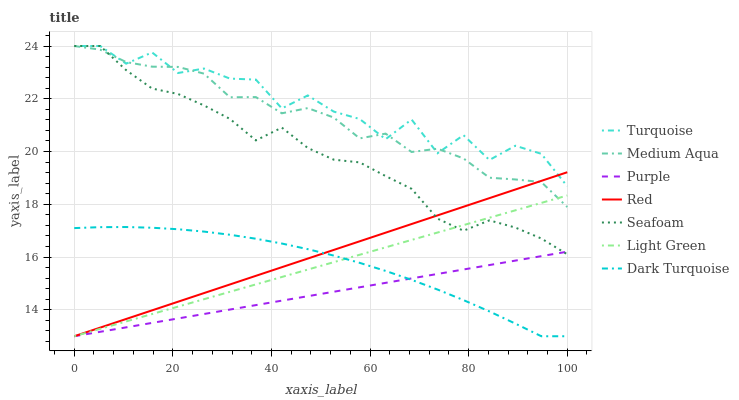Does Purple have the minimum area under the curve?
Answer yes or no. Yes. Does Turquoise have the maximum area under the curve?
Answer yes or no. Yes. Does Dark Turquoise have the minimum area under the curve?
Answer yes or no. No. Does Dark Turquoise have the maximum area under the curve?
Answer yes or no. No. Is Purple the smoothest?
Answer yes or no. Yes. Is Turquoise the roughest?
Answer yes or no. Yes. Is Dark Turquoise the smoothest?
Answer yes or no. No. Is Dark Turquoise the roughest?
Answer yes or no. No. Does Purple have the lowest value?
Answer yes or no. Yes. Does Seafoam have the lowest value?
Answer yes or no. No. Does Medium Aqua have the highest value?
Answer yes or no. Yes. Does Dark Turquoise have the highest value?
Answer yes or no. No. Is Dark Turquoise less than Seafoam?
Answer yes or no. Yes. Is Seafoam greater than Dark Turquoise?
Answer yes or no. Yes. Does Dark Turquoise intersect Light Green?
Answer yes or no. Yes. Is Dark Turquoise less than Light Green?
Answer yes or no. No. Is Dark Turquoise greater than Light Green?
Answer yes or no. No. Does Dark Turquoise intersect Seafoam?
Answer yes or no. No. 